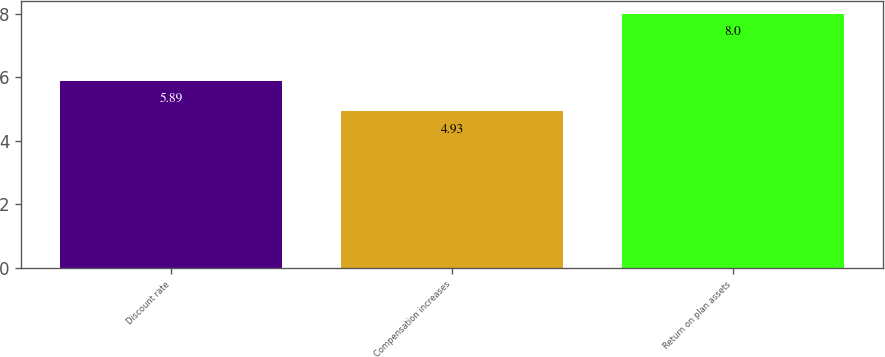Convert chart to OTSL. <chart><loc_0><loc_0><loc_500><loc_500><bar_chart><fcel>Discount rate<fcel>Compensation increases<fcel>Return on plan assets<nl><fcel>5.89<fcel>4.93<fcel>8<nl></chart> 